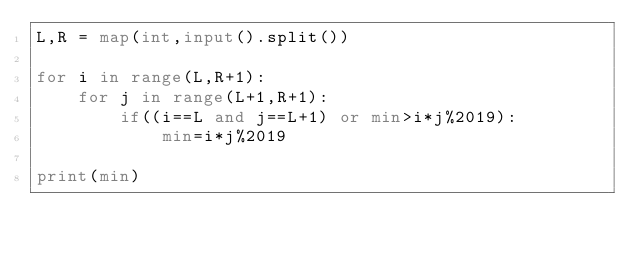Convert code to text. <code><loc_0><loc_0><loc_500><loc_500><_Python_>L,R = map(int,input().split())

for i in range(L,R+1):
    for j in range(L+1,R+1):
        if((i==L and j==L+1) or min>i*j%2019):
            min=i*j%2019

print(min)</code> 